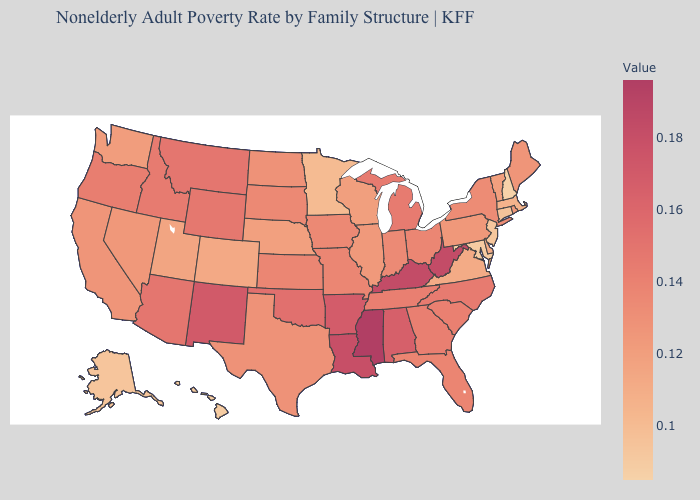Among the states that border Oregon , does Idaho have the lowest value?
Be succinct. No. Does Massachusetts have the lowest value in the Northeast?
Short answer required. No. Does Washington have a lower value than Kentucky?
Quick response, please. Yes. 